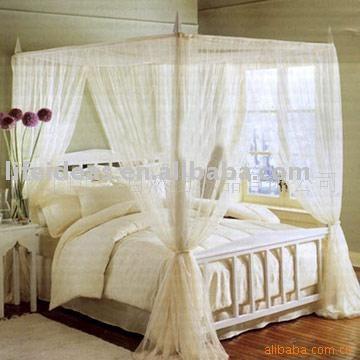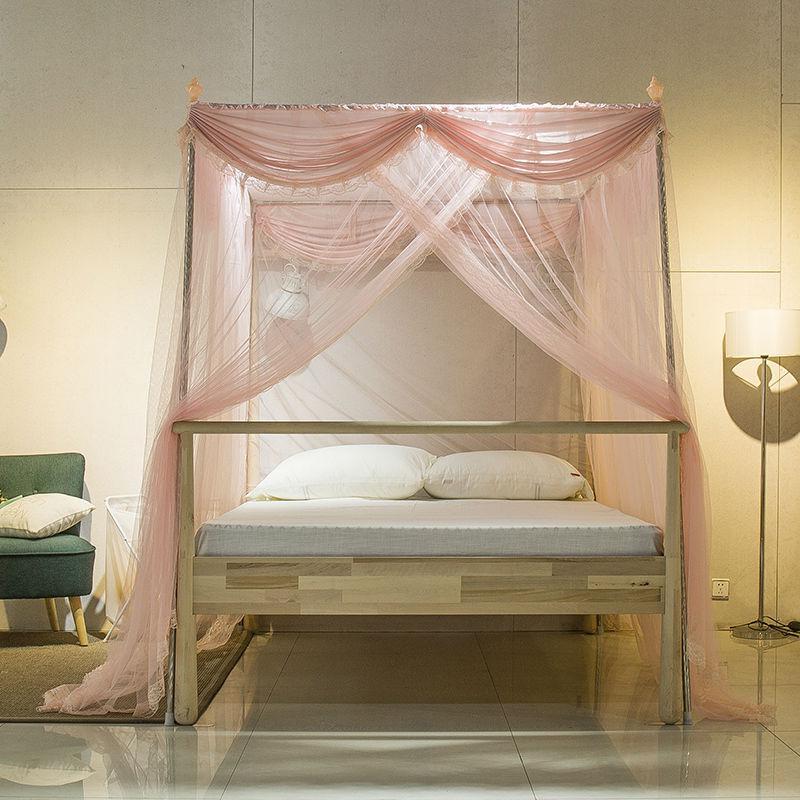The first image is the image on the left, the second image is the image on the right. Given the left and right images, does the statement "The canopy bed on the right has a two-drawer chest next to it." hold true? Answer yes or no. No. The first image is the image on the left, the second image is the image on the right. Given the left and right images, does the statement "Both images show four-posted beds with curtain type canopies." hold true? Answer yes or no. Yes. 